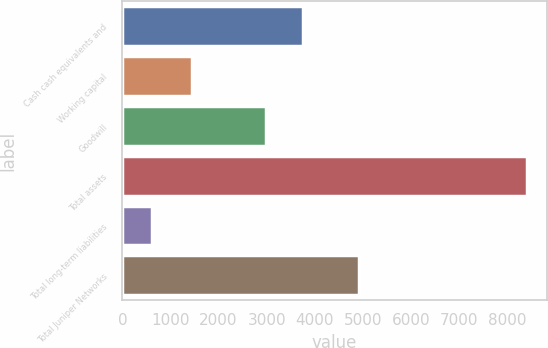Convert chart. <chart><loc_0><loc_0><loc_500><loc_500><bar_chart><fcel>Cash cash equivalents and<fcel>Working capital<fcel>Goodwill<fcel>Total assets<fcel>Total long-term liabilities<fcel>Total Juniper Networks<nl><fcel>3761.08<fcel>1444.2<fcel>2981.5<fcel>8403.1<fcel>607.3<fcel>4919.1<nl></chart> 